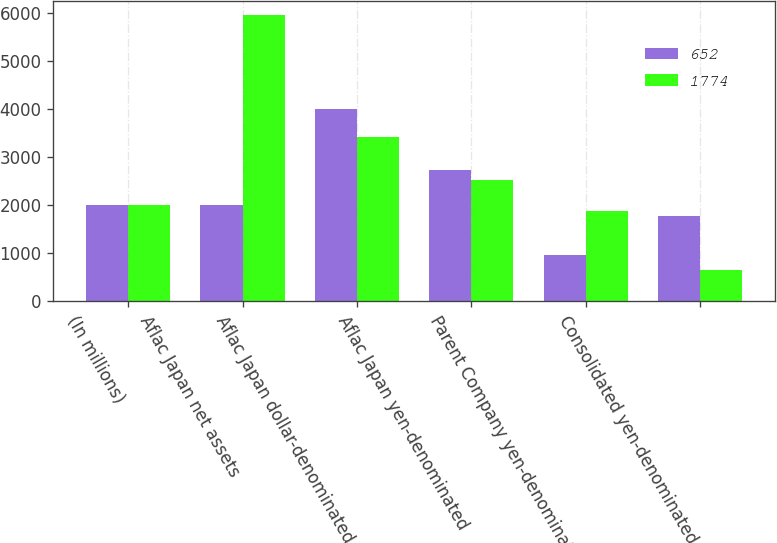<chart> <loc_0><loc_0><loc_500><loc_500><stacked_bar_chart><ecel><fcel>(In millions)<fcel>Aflac Japan net assets<fcel>Aflac Japan dollar-denominated<fcel>Aflac Japan yen-denominated<fcel>Parent Company yen-denominated<fcel>Consolidated yen-denominated<nl><fcel>652<fcel>2009<fcel>2009<fcel>4000<fcel>2736<fcel>962<fcel>1774<nl><fcel>1774<fcel>2008<fcel>5944<fcel>3416<fcel>2528<fcel>1876<fcel>652<nl></chart> 